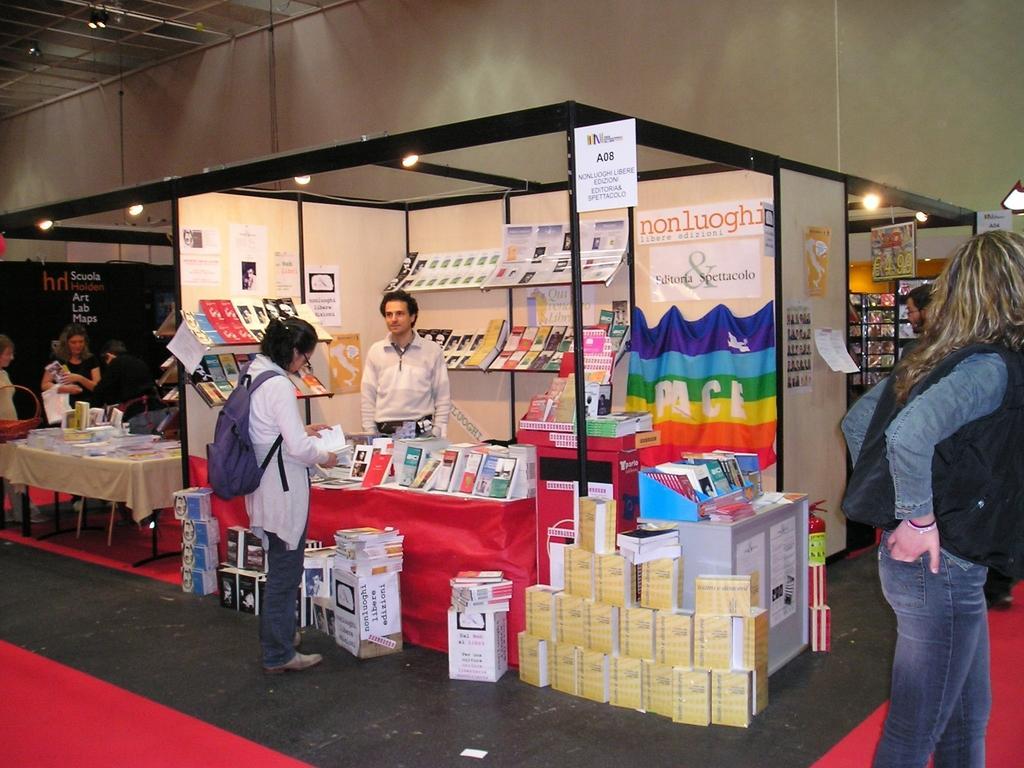Could you give a brief overview of what you see in this image? In this image, we can see few stalls, banners, posters, few objects and lights. In the middle of the image, we can see few people are standing. Few are holding some objects. Here a woman is wearing a backpack. In the background we can see a wall. 